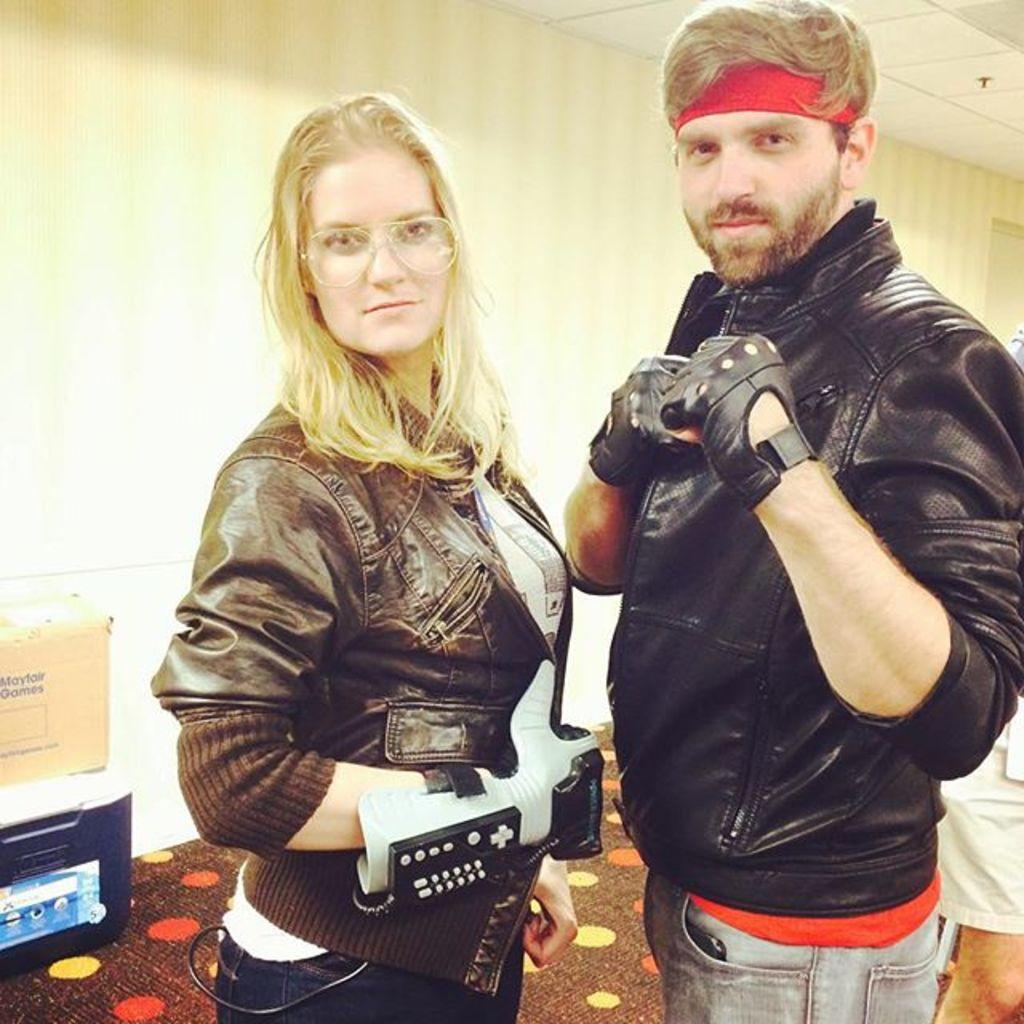How many people are in the image? There are two people standing in the image. What are the people wearing? The people are wearing different color dresses. What can be seen on the floor in the background? There are objects on the floor in the background. What color is the wall in the background? The wall in the background is cream-colored. What type of test is being conducted in the image? There is no indication of a test being conducted in the image. Can you see a whip in the image? There is no whip present in the image. 